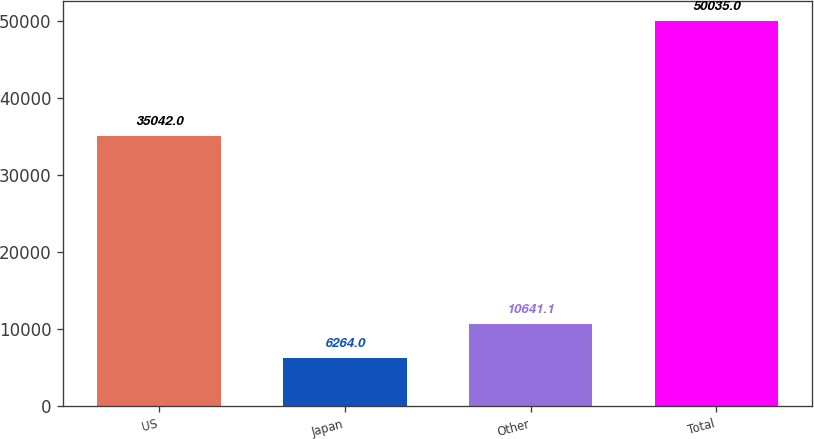<chart> <loc_0><loc_0><loc_500><loc_500><bar_chart><fcel>US<fcel>Japan<fcel>Other<fcel>Total<nl><fcel>35042<fcel>6264<fcel>10641.1<fcel>50035<nl></chart> 